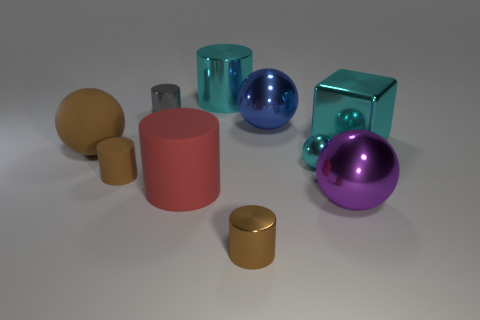There is a blue object that is made of the same material as the cyan cube; what is its shape?
Offer a terse response. Sphere. Is the number of big rubber cylinders less than the number of cylinders?
Keep it short and to the point. Yes. There is a thing that is behind the small cyan ball and on the left side of the tiny gray thing; what material is it?
Offer a very short reply. Rubber. How big is the cyan metal object on the right side of the big shiny sphere on the right side of the blue metallic object behind the tiny rubber cylinder?
Offer a very short reply. Large. There is a big purple shiny thing; is its shape the same as the small cyan metallic thing that is behind the large red cylinder?
Offer a terse response. Yes. What number of metallic things are both in front of the cyan shiny cube and to the right of the purple ball?
Offer a terse response. 0. What number of gray objects are large things or small shiny cylinders?
Your response must be concise. 1. There is a small object to the right of the big blue shiny sphere; does it have the same color as the big shiny cylinder right of the small brown rubber cylinder?
Give a very brief answer. Yes. What color is the big cylinder on the left side of the large cyan object to the left of the metallic thing in front of the large purple metal sphere?
Keep it short and to the point. Red. There is a cyan metallic object that is in front of the cube; are there any large objects behind it?
Your answer should be very brief. Yes. 